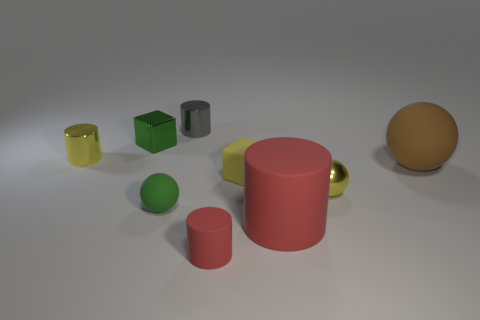What number of rubber spheres are the same size as the yellow rubber cube?
Give a very brief answer. 1. What shape is the green object in front of the rubber sphere that is right of the tiny rubber block?
Give a very brief answer. Sphere. Is the number of green metal blocks less than the number of blue metallic objects?
Your response must be concise. No. The cylinder left of the green block is what color?
Keep it short and to the point. Yellow. There is a sphere that is to the right of the small matte cube and on the left side of the big matte sphere; what material is it?
Ensure brevity in your answer.  Metal. There is a small yellow thing that is the same material as the small red cylinder; what is its shape?
Ensure brevity in your answer.  Cube. There is a tiny rubber thing that is to the right of the small red rubber cylinder; how many metal spheres are right of it?
Make the answer very short. 1. What number of tiny things are both behind the tiny rubber cube and in front of the small green metallic block?
Your response must be concise. 1. How many other things are there of the same material as the gray object?
Your answer should be very brief. 3. There is a ball that is in front of the small sphere that is behind the small rubber ball; what is its color?
Ensure brevity in your answer.  Green. 